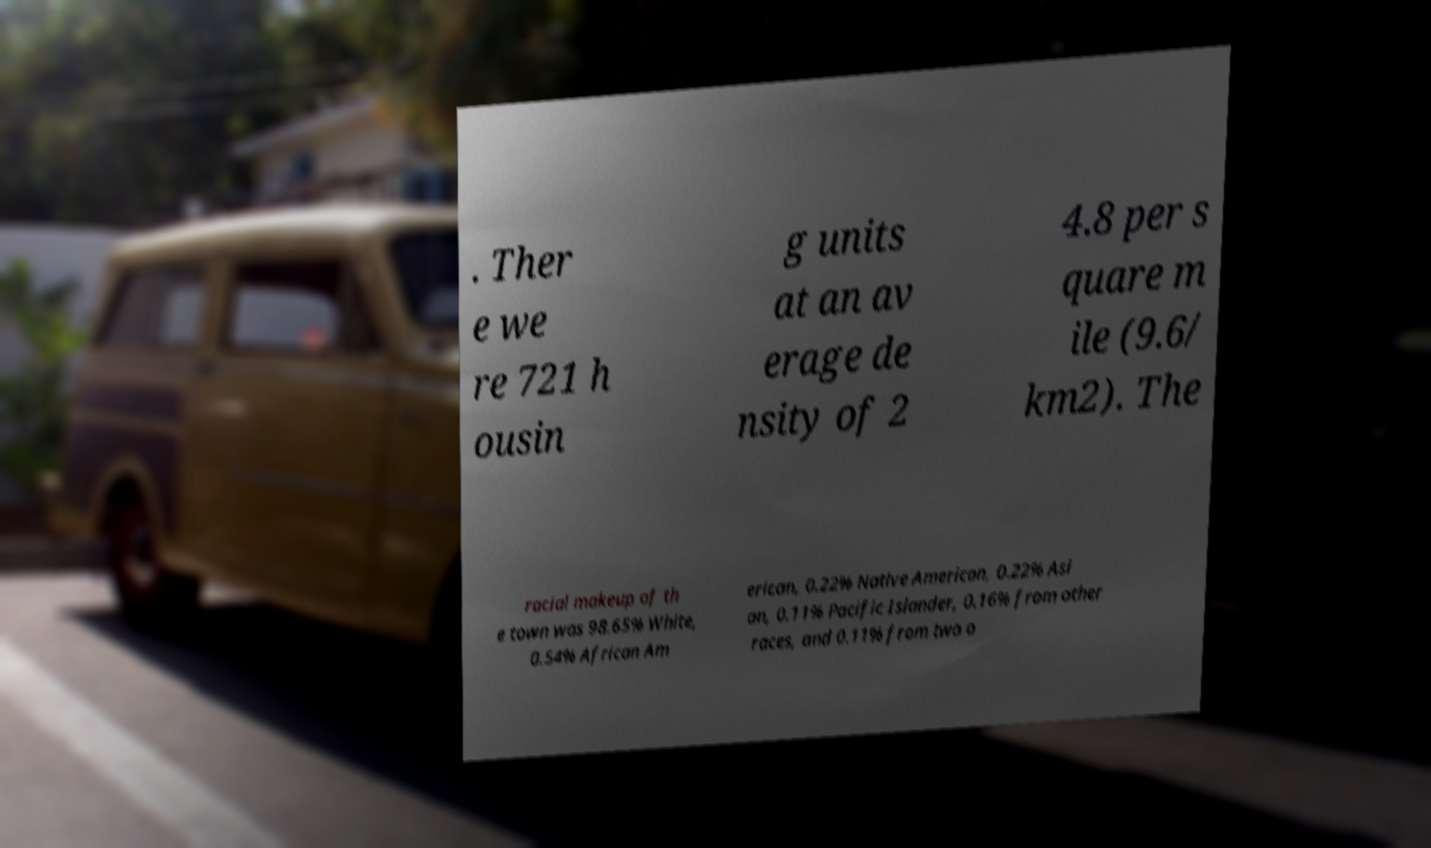Could you extract and type out the text from this image? . Ther e we re 721 h ousin g units at an av erage de nsity of 2 4.8 per s quare m ile (9.6/ km2). The racial makeup of th e town was 98.65% White, 0.54% African Am erican, 0.22% Native American, 0.22% Asi an, 0.11% Pacific Islander, 0.16% from other races, and 0.11% from two o 